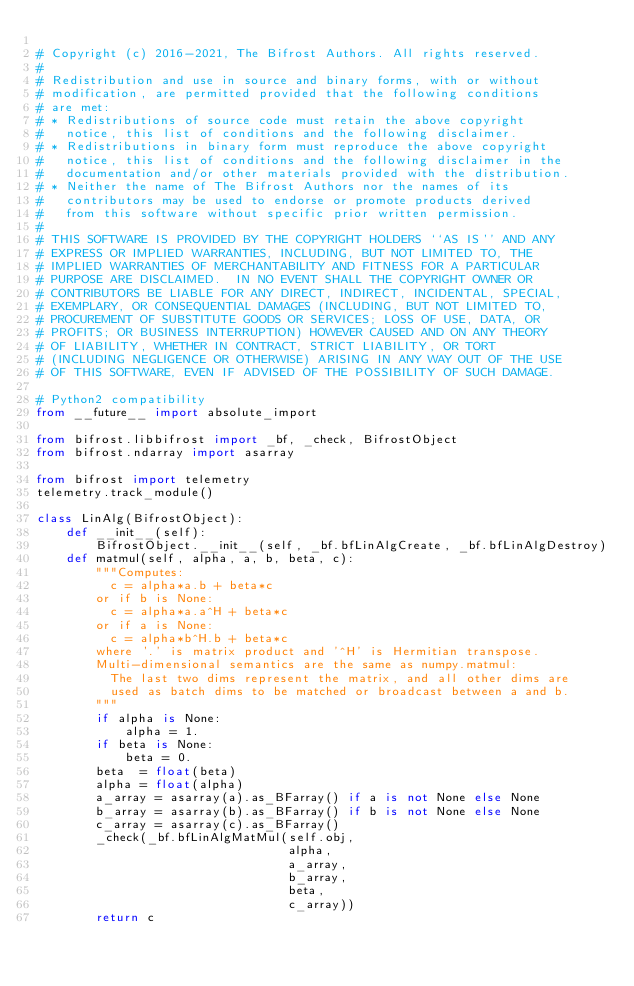Convert code to text. <code><loc_0><loc_0><loc_500><loc_500><_Python_>
# Copyright (c) 2016-2021, The Bifrost Authors. All rights reserved.
#
# Redistribution and use in source and binary forms, with or without
# modification, are permitted provided that the following conditions
# are met:
# * Redistributions of source code must retain the above copyright
#   notice, this list of conditions and the following disclaimer.
# * Redistributions in binary form must reproduce the above copyright
#   notice, this list of conditions and the following disclaimer in the
#   documentation and/or other materials provided with the distribution.
# * Neither the name of The Bifrost Authors nor the names of its
#   contributors may be used to endorse or promote products derived
#   from this software without specific prior written permission.
#
# THIS SOFTWARE IS PROVIDED BY THE COPYRIGHT HOLDERS ``AS IS'' AND ANY
# EXPRESS OR IMPLIED WARRANTIES, INCLUDING, BUT NOT LIMITED TO, THE
# IMPLIED WARRANTIES OF MERCHANTABILITY AND FITNESS FOR A PARTICULAR
# PURPOSE ARE DISCLAIMED.  IN NO EVENT SHALL THE COPYRIGHT OWNER OR
# CONTRIBUTORS BE LIABLE FOR ANY DIRECT, INDIRECT, INCIDENTAL, SPECIAL,
# EXEMPLARY, OR CONSEQUENTIAL DAMAGES (INCLUDING, BUT NOT LIMITED TO,
# PROCUREMENT OF SUBSTITUTE GOODS OR SERVICES; LOSS OF USE, DATA, OR
# PROFITS; OR BUSINESS INTERRUPTION) HOWEVER CAUSED AND ON ANY THEORY
# OF LIABILITY, WHETHER IN CONTRACT, STRICT LIABILITY, OR TORT
# (INCLUDING NEGLIGENCE OR OTHERWISE) ARISING IN ANY WAY OUT OF THE USE
# OF THIS SOFTWARE, EVEN IF ADVISED OF THE POSSIBILITY OF SUCH DAMAGE.

# Python2 compatibility
from __future__ import absolute_import

from bifrost.libbifrost import _bf, _check, BifrostObject
from bifrost.ndarray import asarray

from bifrost import telemetry
telemetry.track_module()

class LinAlg(BifrostObject):
    def __init__(self):
        BifrostObject.__init__(self, _bf.bfLinAlgCreate, _bf.bfLinAlgDestroy)
    def matmul(self, alpha, a, b, beta, c):
        """Computes:
          c = alpha*a.b + beta*c
        or if b is None:
          c = alpha*a.a^H + beta*c
        or if a is None:
          c = alpha*b^H.b + beta*c
        where '.' is matrix product and '^H' is Hermitian transpose.
        Multi-dimensional semantics are the same as numpy.matmul:
          The last two dims represent the matrix, and all other dims are
          used as batch dims to be matched or broadcast between a and b.
        """
        if alpha is None:
            alpha = 1.
        if beta is None:
            beta = 0.
        beta  = float(beta)
        alpha = float(alpha)
        a_array = asarray(a).as_BFarray() if a is not None else None
        b_array = asarray(b).as_BFarray() if b is not None else None
        c_array = asarray(c).as_BFarray()
        _check(_bf.bfLinAlgMatMul(self.obj,
                                  alpha,
                                  a_array,
                                  b_array,
                                  beta,
                                  c_array))
        return c
</code> 